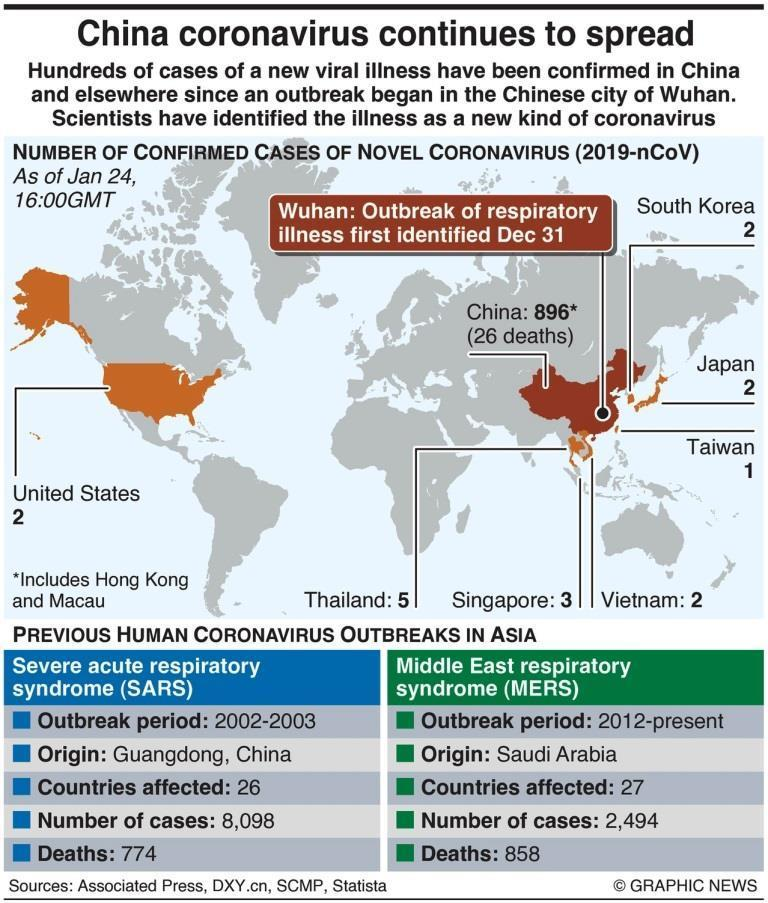When was the SARS virus first identified in China?
Answer the question with a short phrase. 2002 How many Covid-19 cases were reported in Singapore as of January 24? 3 When did the SARS outbreak ended? 2003 How many countries were affected by the MERS disease outbreak? 27 Where was the first case of MERS identified? Saudi Arabia How many countries were affected by the SARS disease outbreak? 26 When was the MERS virus first identified in Saudi Arabia? 2012 How many cases of SARS virus were reported? 8,098 Where was the first case of SARS identified? Guangdong, China What is the number of deaths caused by the SARS virus? 774 